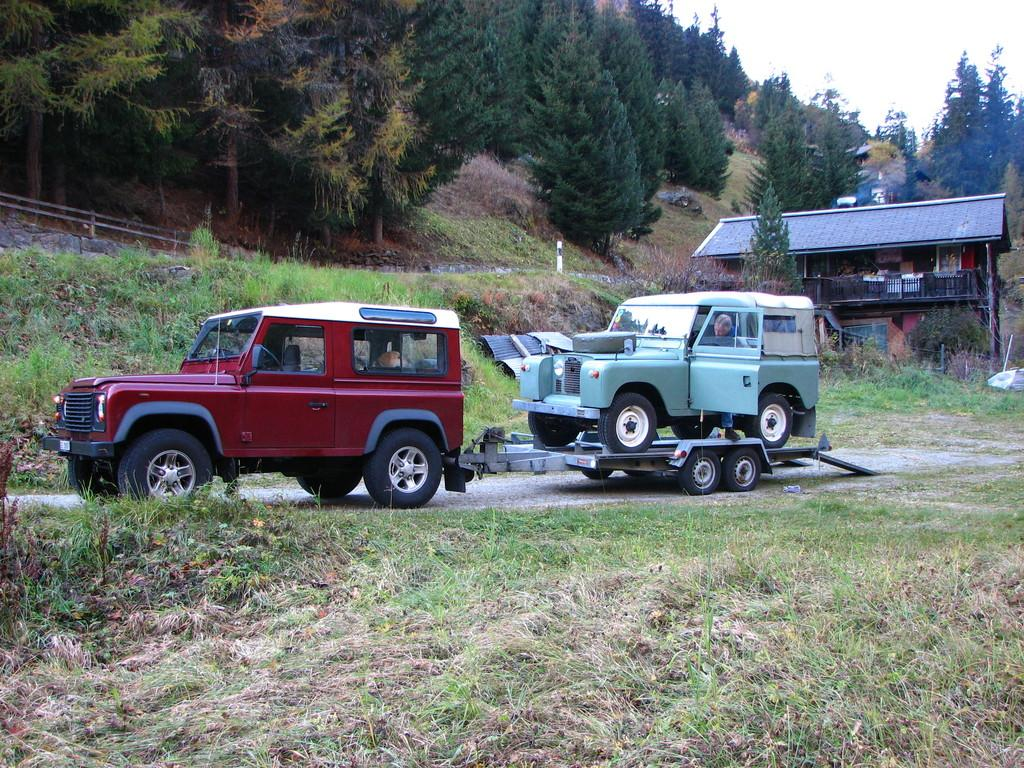What is the main subject in the center of the image? There are vehicles on the road in the center of the image. What type of surface can be seen in the image? There is grass on the surface. What structure is located on the backside of the image? There is a building on the backside of the image. What type of vegetation is visible in the background of the image? There are trees in the background of the image. What is visible in the background of the image besides the trees? The sky is visible in the background of the image. Where is the vase of plants located in the image? There is no vase of plants present in the image. 